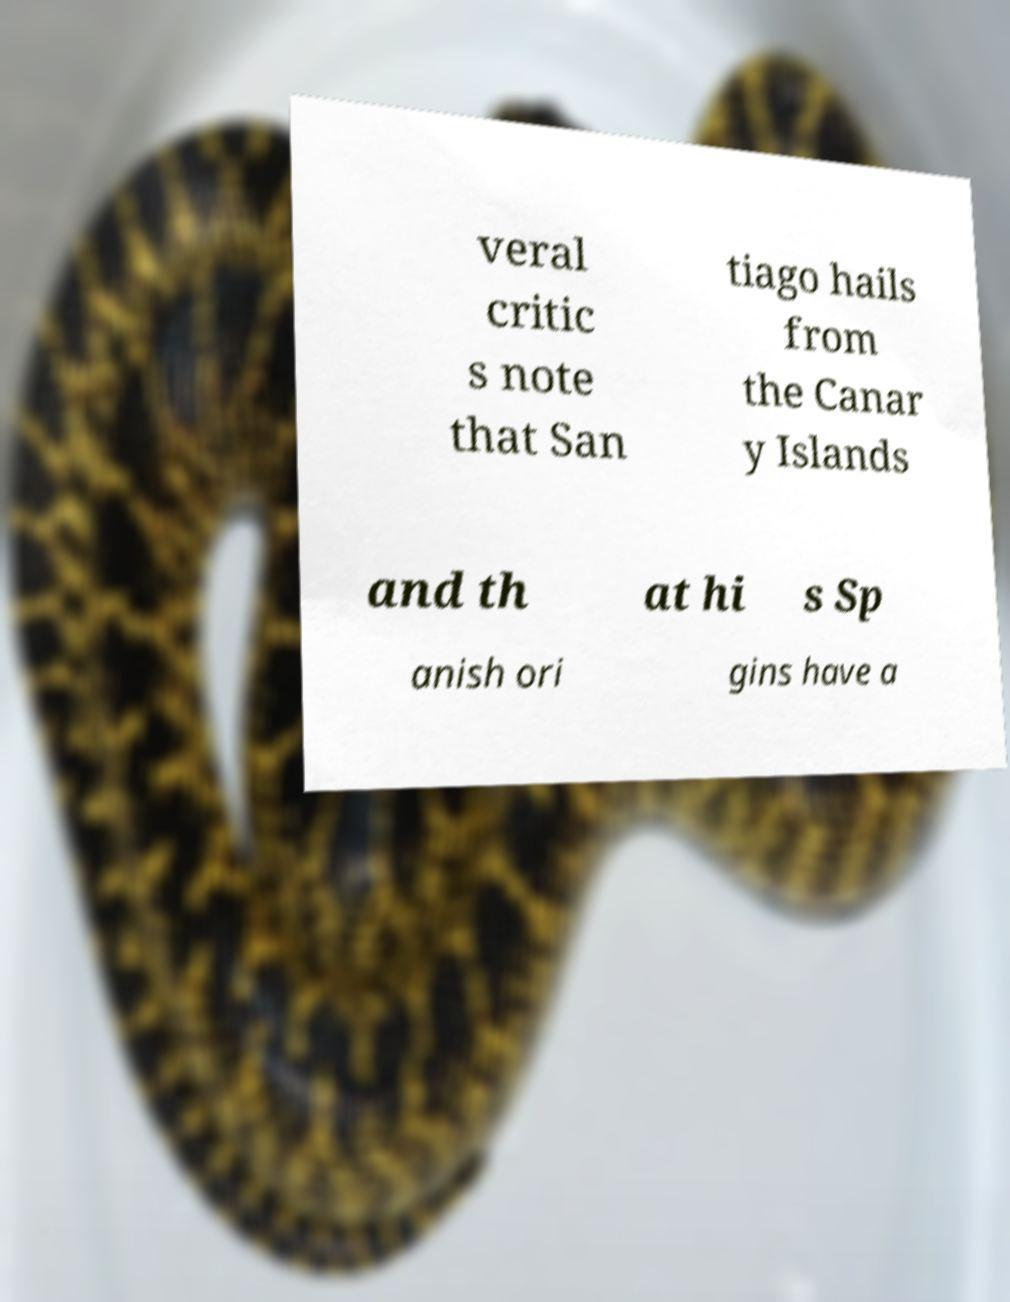I need the written content from this picture converted into text. Can you do that? veral critic s note that San tiago hails from the Canar y Islands and th at hi s Sp anish ori gins have a 